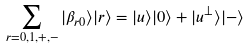Convert formula to latex. <formula><loc_0><loc_0><loc_500><loc_500>\sum _ { r = 0 , 1 , + , - } | \beta _ { r 0 } \rangle | r \rangle = | u \rangle | 0 \rangle + | u ^ { \perp } \rangle | - \rangle</formula> 